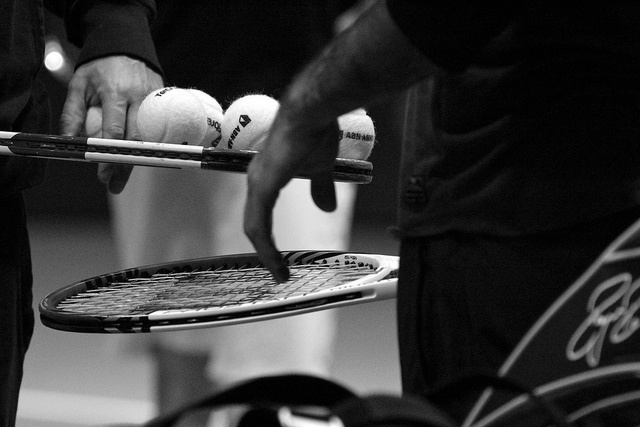Describe the objects in this image and their specific colors. I can see people in black, gray, darkgray, and lightgray tones, people in black, darkgray, gray, and lightgray tones, tennis racket in black, gray, darkgray, and gainsboro tones, tennis racket in black, gray, darkgray, and lightgray tones, and sports ball in black, lightgray, darkgray, and gray tones in this image. 